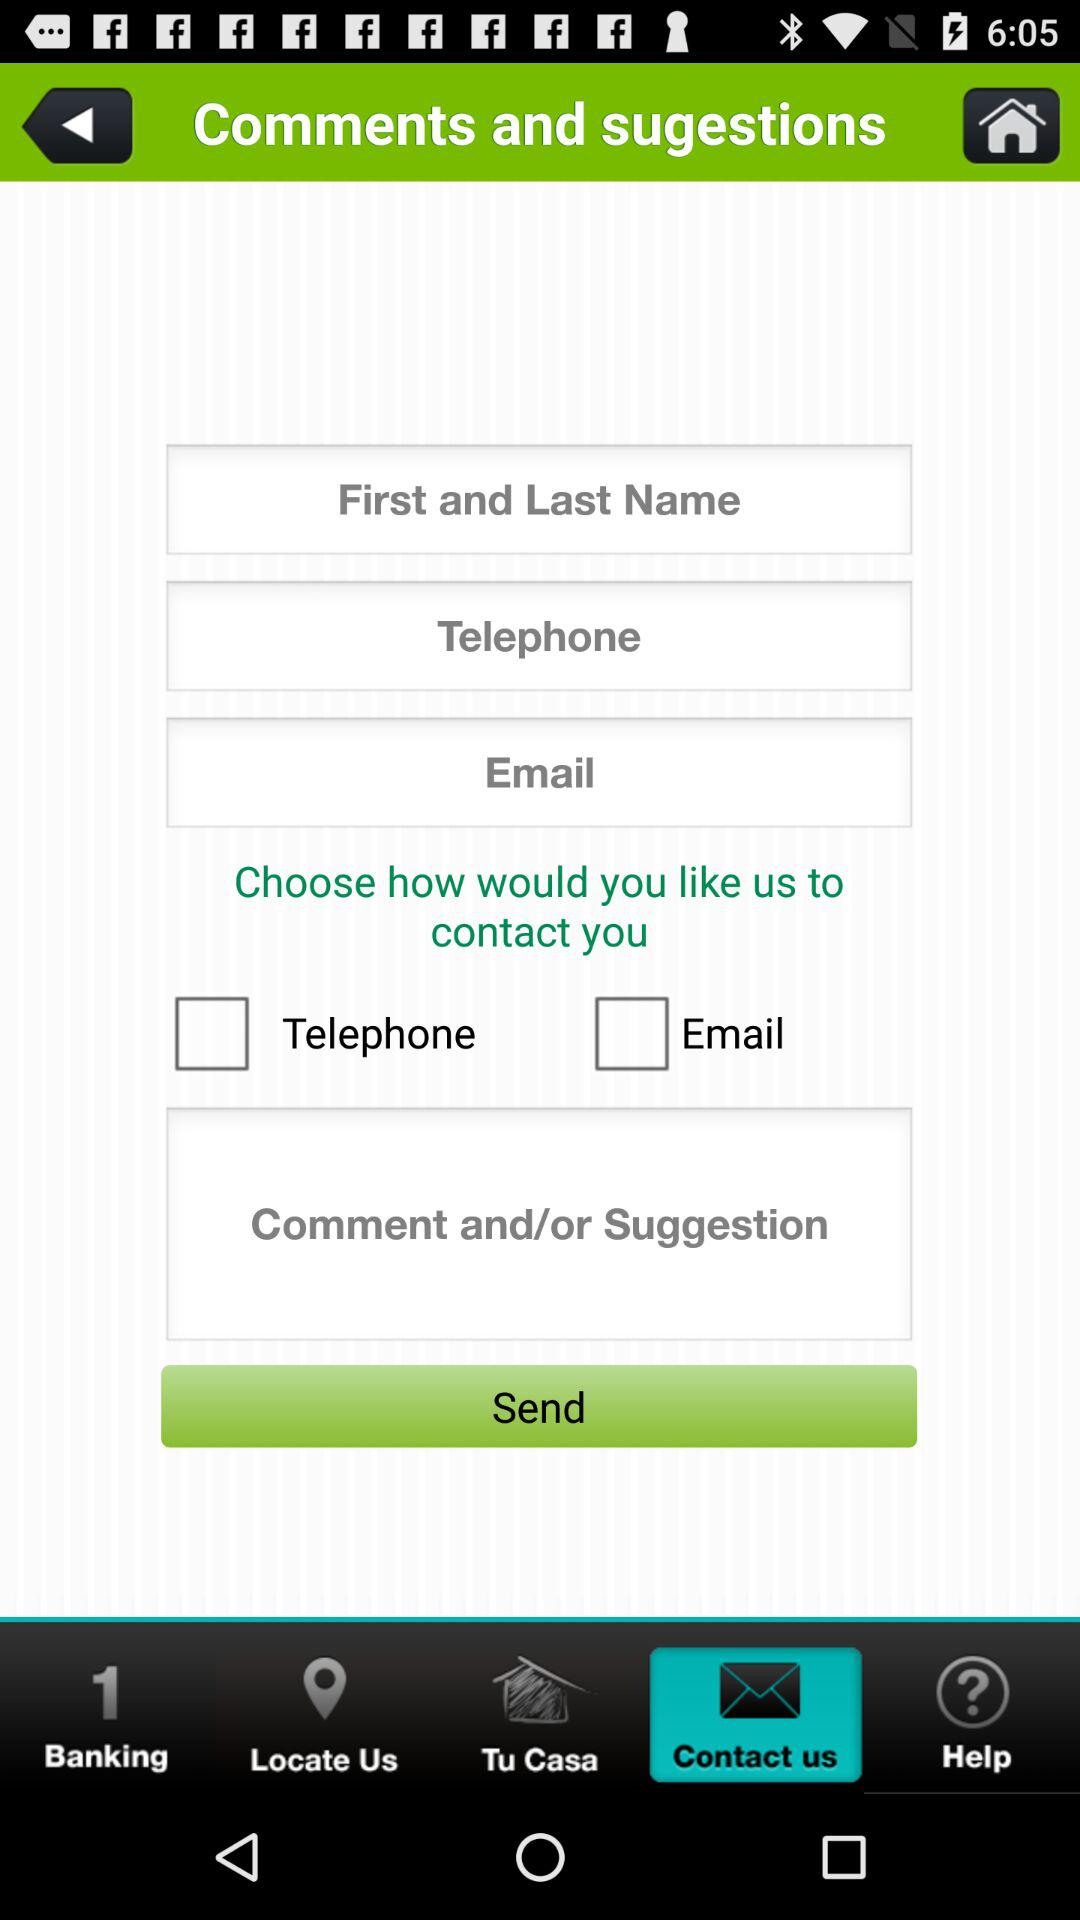Which tab is selected? The selected tab is "Contact us". 